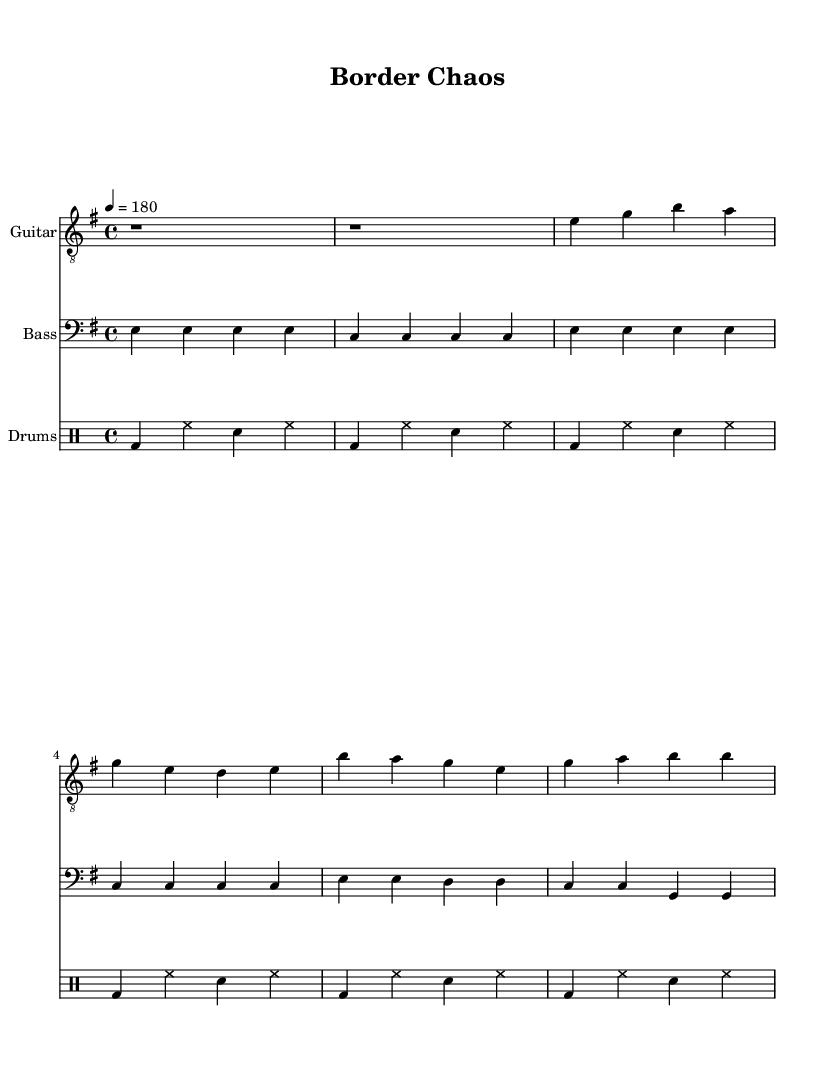What is the key signature of this music? The key signature is E minor, which has one sharp (F#) and is indicated at the beginning of the score.
Answer: E minor What is the time signature of this music? The time signature is 4/4, as noted at the start of the score. It means there are four beats in each measure, with a quarter note receiving one beat.
Answer: 4/4 What is the tempo marking for this piece? The tempo marking is 180, which indicates the speed of the piece. It's stated at the beginning with "4 = 180," meaning 180 beats per minute.
Answer: 180 What is the total number of measures in the verse section? The verse section contains four measures, as counted from the music for the verse lyrics. Each line of lyrics corresponds to one measure of music.
Answer: 4 How many distinct instruments are used in this piece? There are three distinct instruments: Guitar, Bass, and Drums. Each has its own staff in the score, showing the parts played by each instrument.
Answer: 3 What is the main theme expressed in the lyrics of the verse? The main theme expressed in the lyrics of the verse is about chaos at the border and the failure of politicians to provide solutions, indicating a political commentary on border security.
Answer: Border chaos How does the chorus relate to the verse musically? The chorus closely matches the verse in structure but amplifies the urgency of securing the border, making it a thematic continuation rather than a total departure, emphasizing a call to action.
Answer: Urgency for action 